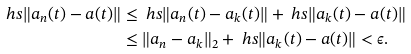Convert formula to latex. <formula><loc_0><loc_0><loc_500><loc_500>\ h s \| a _ { n } ( t ) - a ( t ) \| & \leq \ h s \| a _ { n } ( t ) - a _ { k } ( t ) \| + \ h s \| a _ { k } ( t ) - a ( t ) \| \\ & \leq \| a _ { n } - a _ { k } \| _ { 2 } + \ h s \| a _ { k } ( t ) - a ( t ) \| < \epsilon .</formula> 